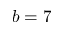<formula> <loc_0><loc_0><loc_500><loc_500>b = 7</formula> 